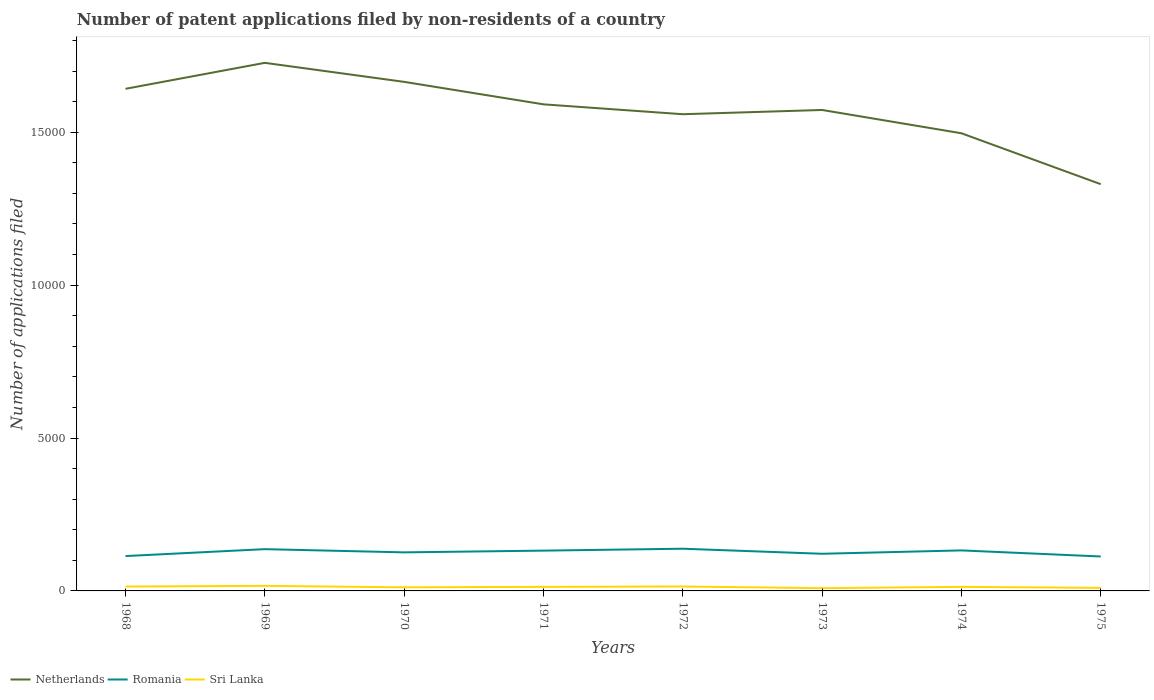How many different coloured lines are there?
Your response must be concise. 3. Across all years, what is the maximum number of applications filed in Romania?
Make the answer very short. 1126. What is the difference between the highest and the second highest number of applications filed in Netherlands?
Your answer should be very brief. 3968. What is the difference between the highest and the lowest number of applications filed in Netherlands?
Your response must be concise. 4. Is the number of applications filed in Netherlands strictly greater than the number of applications filed in Sri Lanka over the years?
Provide a short and direct response. No. How many years are there in the graph?
Make the answer very short. 8. Are the values on the major ticks of Y-axis written in scientific E-notation?
Keep it short and to the point. No. Does the graph contain any zero values?
Provide a short and direct response. No. Where does the legend appear in the graph?
Provide a short and direct response. Bottom left. How many legend labels are there?
Provide a short and direct response. 3. What is the title of the graph?
Offer a terse response. Number of patent applications filed by non-residents of a country. Does "Cayman Islands" appear as one of the legend labels in the graph?
Make the answer very short. No. What is the label or title of the Y-axis?
Your response must be concise. Number of applications filed. What is the Number of applications filed of Netherlands in 1968?
Provide a succinct answer. 1.64e+04. What is the Number of applications filed of Romania in 1968?
Keep it short and to the point. 1140. What is the Number of applications filed of Sri Lanka in 1968?
Offer a very short reply. 143. What is the Number of applications filed in Netherlands in 1969?
Provide a succinct answer. 1.73e+04. What is the Number of applications filed of Romania in 1969?
Keep it short and to the point. 1366. What is the Number of applications filed of Sri Lanka in 1969?
Ensure brevity in your answer.  166. What is the Number of applications filed in Netherlands in 1970?
Your answer should be compact. 1.66e+04. What is the Number of applications filed of Romania in 1970?
Your response must be concise. 1261. What is the Number of applications filed in Sri Lanka in 1970?
Give a very brief answer. 118. What is the Number of applications filed of Netherlands in 1971?
Your answer should be compact. 1.59e+04. What is the Number of applications filed in Romania in 1971?
Your answer should be very brief. 1318. What is the Number of applications filed of Sri Lanka in 1971?
Keep it short and to the point. 133. What is the Number of applications filed in Netherlands in 1972?
Make the answer very short. 1.56e+04. What is the Number of applications filed of Romania in 1972?
Your response must be concise. 1380. What is the Number of applications filed in Sri Lanka in 1972?
Your answer should be very brief. 145. What is the Number of applications filed of Netherlands in 1973?
Your answer should be very brief. 1.57e+04. What is the Number of applications filed of Romania in 1973?
Make the answer very short. 1215. What is the Number of applications filed in Netherlands in 1974?
Ensure brevity in your answer.  1.50e+04. What is the Number of applications filed in Romania in 1974?
Provide a succinct answer. 1325. What is the Number of applications filed in Sri Lanka in 1974?
Make the answer very short. 133. What is the Number of applications filed of Netherlands in 1975?
Offer a terse response. 1.33e+04. What is the Number of applications filed in Romania in 1975?
Keep it short and to the point. 1126. What is the Number of applications filed of Sri Lanka in 1975?
Ensure brevity in your answer.  99. Across all years, what is the maximum Number of applications filed in Netherlands?
Offer a very short reply. 1.73e+04. Across all years, what is the maximum Number of applications filed of Romania?
Offer a terse response. 1380. Across all years, what is the maximum Number of applications filed of Sri Lanka?
Make the answer very short. 166. Across all years, what is the minimum Number of applications filed of Netherlands?
Ensure brevity in your answer.  1.33e+04. Across all years, what is the minimum Number of applications filed in Romania?
Offer a terse response. 1126. Across all years, what is the minimum Number of applications filed in Sri Lanka?
Make the answer very short. 90. What is the total Number of applications filed of Netherlands in the graph?
Ensure brevity in your answer.  1.26e+05. What is the total Number of applications filed in Romania in the graph?
Offer a very short reply. 1.01e+04. What is the total Number of applications filed of Sri Lanka in the graph?
Provide a short and direct response. 1027. What is the difference between the Number of applications filed in Netherlands in 1968 and that in 1969?
Offer a terse response. -849. What is the difference between the Number of applications filed in Romania in 1968 and that in 1969?
Provide a short and direct response. -226. What is the difference between the Number of applications filed in Sri Lanka in 1968 and that in 1969?
Provide a succinct answer. -23. What is the difference between the Number of applications filed in Netherlands in 1968 and that in 1970?
Provide a short and direct response. -227. What is the difference between the Number of applications filed of Romania in 1968 and that in 1970?
Your answer should be very brief. -121. What is the difference between the Number of applications filed in Sri Lanka in 1968 and that in 1970?
Your answer should be very brief. 25. What is the difference between the Number of applications filed of Netherlands in 1968 and that in 1971?
Your response must be concise. 508. What is the difference between the Number of applications filed of Romania in 1968 and that in 1971?
Make the answer very short. -178. What is the difference between the Number of applications filed in Netherlands in 1968 and that in 1972?
Ensure brevity in your answer.  831. What is the difference between the Number of applications filed in Romania in 1968 and that in 1972?
Make the answer very short. -240. What is the difference between the Number of applications filed in Netherlands in 1968 and that in 1973?
Make the answer very short. 692. What is the difference between the Number of applications filed in Romania in 1968 and that in 1973?
Your answer should be very brief. -75. What is the difference between the Number of applications filed of Netherlands in 1968 and that in 1974?
Ensure brevity in your answer.  1454. What is the difference between the Number of applications filed in Romania in 1968 and that in 1974?
Offer a very short reply. -185. What is the difference between the Number of applications filed of Netherlands in 1968 and that in 1975?
Offer a very short reply. 3119. What is the difference between the Number of applications filed of Sri Lanka in 1968 and that in 1975?
Keep it short and to the point. 44. What is the difference between the Number of applications filed of Netherlands in 1969 and that in 1970?
Your answer should be very brief. 622. What is the difference between the Number of applications filed in Romania in 1969 and that in 1970?
Provide a succinct answer. 105. What is the difference between the Number of applications filed in Sri Lanka in 1969 and that in 1970?
Offer a terse response. 48. What is the difference between the Number of applications filed of Netherlands in 1969 and that in 1971?
Offer a very short reply. 1357. What is the difference between the Number of applications filed in Sri Lanka in 1969 and that in 1971?
Your answer should be compact. 33. What is the difference between the Number of applications filed of Netherlands in 1969 and that in 1972?
Your answer should be very brief. 1680. What is the difference between the Number of applications filed of Romania in 1969 and that in 1972?
Offer a terse response. -14. What is the difference between the Number of applications filed of Netherlands in 1969 and that in 1973?
Your response must be concise. 1541. What is the difference between the Number of applications filed in Romania in 1969 and that in 1973?
Give a very brief answer. 151. What is the difference between the Number of applications filed in Netherlands in 1969 and that in 1974?
Keep it short and to the point. 2303. What is the difference between the Number of applications filed in Romania in 1969 and that in 1974?
Make the answer very short. 41. What is the difference between the Number of applications filed in Netherlands in 1969 and that in 1975?
Provide a short and direct response. 3968. What is the difference between the Number of applications filed of Romania in 1969 and that in 1975?
Ensure brevity in your answer.  240. What is the difference between the Number of applications filed in Sri Lanka in 1969 and that in 1975?
Your answer should be very brief. 67. What is the difference between the Number of applications filed in Netherlands in 1970 and that in 1971?
Provide a succinct answer. 735. What is the difference between the Number of applications filed in Romania in 1970 and that in 1971?
Provide a succinct answer. -57. What is the difference between the Number of applications filed of Netherlands in 1970 and that in 1972?
Your answer should be very brief. 1058. What is the difference between the Number of applications filed in Romania in 1970 and that in 1972?
Provide a succinct answer. -119. What is the difference between the Number of applications filed of Netherlands in 1970 and that in 1973?
Provide a succinct answer. 919. What is the difference between the Number of applications filed in Netherlands in 1970 and that in 1974?
Keep it short and to the point. 1681. What is the difference between the Number of applications filed in Romania in 1970 and that in 1974?
Offer a terse response. -64. What is the difference between the Number of applications filed of Sri Lanka in 1970 and that in 1974?
Offer a terse response. -15. What is the difference between the Number of applications filed of Netherlands in 1970 and that in 1975?
Make the answer very short. 3346. What is the difference between the Number of applications filed in Romania in 1970 and that in 1975?
Keep it short and to the point. 135. What is the difference between the Number of applications filed in Netherlands in 1971 and that in 1972?
Ensure brevity in your answer.  323. What is the difference between the Number of applications filed in Romania in 1971 and that in 1972?
Your response must be concise. -62. What is the difference between the Number of applications filed of Netherlands in 1971 and that in 1973?
Keep it short and to the point. 184. What is the difference between the Number of applications filed in Romania in 1971 and that in 1973?
Provide a succinct answer. 103. What is the difference between the Number of applications filed in Netherlands in 1971 and that in 1974?
Your response must be concise. 946. What is the difference between the Number of applications filed in Romania in 1971 and that in 1974?
Provide a succinct answer. -7. What is the difference between the Number of applications filed of Sri Lanka in 1971 and that in 1974?
Your answer should be very brief. 0. What is the difference between the Number of applications filed of Netherlands in 1971 and that in 1975?
Your response must be concise. 2611. What is the difference between the Number of applications filed of Romania in 1971 and that in 1975?
Your answer should be very brief. 192. What is the difference between the Number of applications filed of Sri Lanka in 1971 and that in 1975?
Your response must be concise. 34. What is the difference between the Number of applications filed of Netherlands in 1972 and that in 1973?
Your answer should be compact. -139. What is the difference between the Number of applications filed of Romania in 1972 and that in 1973?
Keep it short and to the point. 165. What is the difference between the Number of applications filed of Sri Lanka in 1972 and that in 1973?
Your response must be concise. 55. What is the difference between the Number of applications filed in Netherlands in 1972 and that in 1974?
Provide a short and direct response. 623. What is the difference between the Number of applications filed of Romania in 1972 and that in 1974?
Offer a terse response. 55. What is the difference between the Number of applications filed in Sri Lanka in 1972 and that in 1974?
Offer a very short reply. 12. What is the difference between the Number of applications filed of Netherlands in 1972 and that in 1975?
Make the answer very short. 2288. What is the difference between the Number of applications filed in Romania in 1972 and that in 1975?
Make the answer very short. 254. What is the difference between the Number of applications filed of Sri Lanka in 1972 and that in 1975?
Ensure brevity in your answer.  46. What is the difference between the Number of applications filed of Netherlands in 1973 and that in 1974?
Ensure brevity in your answer.  762. What is the difference between the Number of applications filed in Romania in 1973 and that in 1974?
Ensure brevity in your answer.  -110. What is the difference between the Number of applications filed of Sri Lanka in 1973 and that in 1974?
Provide a succinct answer. -43. What is the difference between the Number of applications filed in Netherlands in 1973 and that in 1975?
Keep it short and to the point. 2427. What is the difference between the Number of applications filed in Romania in 1973 and that in 1975?
Ensure brevity in your answer.  89. What is the difference between the Number of applications filed in Netherlands in 1974 and that in 1975?
Provide a succinct answer. 1665. What is the difference between the Number of applications filed of Romania in 1974 and that in 1975?
Your answer should be very brief. 199. What is the difference between the Number of applications filed of Sri Lanka in 1974 and that in 1975?
Offer a very short reply. 34. What is the difference between the Number of applications filed in Netherlands in 1968 and the Number of applications filed in Romania in 1969?
Offer a very short reply. 1.51e+04. What is the difference between the Number of applications filed in Netherlands in 1968 and the Number of applications filed in Sri Lanka in 1969?
Your answer should be very brief. 1.63e+04. What is the difference between the Number of applications filed in Romania in 1968 and the Number of applications filed in Sri Lanka in 1969?
Your answer should be compact. 974. What is the difference between the Number of applications filed of Netherlands in 1968 and the Number of applications filed of Romania in 1970?
Offer a terse response. 1.52e+04. What is the difference between the Number of applications filed in Netherlands in 1968 and the Number of applications filed in Sri Lanka in 1970?
Your response must be concise. 1.63e+04. What is the difference between the Number of applications filed of Romania in 1968 and the Number of applications filed of Sri Lanka in 1970?
Offer a very short reply. 1022. What is the difference between the Number of applications filed of Netherlands in 1968 and the Number of applications filed of Romania in 1971?
Offer a terse response. 1.51e+04. What is the difference between the Number of applications filed of Netherlands in 1968 and the Number of applications filed of Sri Lanka in 1971?
Offer a terse response. 1.63e+04. What is the difference between the Number of applications filed of Romania in 1968 and the Number of applications filed of Sri Lanka in 1971?
Offer a terse response. 1007. What is the difference between the Number of applications filed in Netherlands in 1968 and the Number of applications filed in Romania in 1972?
Ensure brevity in your answer.  1.50e+04. What is the difference between the Number of applications filed in Netherlands in 1968 and the Number of applications filed in Sri Lanka in 1972?
Your answer should be compact. 1.63e+04. What is the difference between the Number of applications filed of Romania in 1968 and the Number of applications filed of Sri Lanka in 1972?
Ensure brevity in your answer.  995. What is the difference between the Number of applications filed of Netherlands in 1968 and the Number of applications filed of Romania in 1973?
Your answer should be compact. 1.52e+04. What is the difference between the Number of applications filed of Netherlands in 1968 and the Number of applications filed of Sri Lanka in 1973?
Provide a short and direct response. 1.63e+04. What is the difference between the Number of applications filed in Romania in 1968 and the Number of applications filed in Sri Lanka in 1973?
Your answer should be very brief. 1050. What is the difference between the Number of applications filed in Netherlands in 1968 and the Number of applications filed in Romania in 1974?
Offer a very short reply. 1.51e+04. What is the difference between the Number of applications filed in Netherlands in 1968 and the Number of applications filed in Sri Lanka in 1974?
Offer a very short reply. 1.63e+04. What is the difference between the Number of applications filed in Romania in 1968 and the Number of applications filed in Sri Lanka in 1974?
Keep it short and to the point. 1007. What is the difference between the Number of applications filed in Netherlands in 1968 and the Number of applications filed in Romania in 1975?
Provide a short and direct response. 1.53e+04. What is the difference between the Number of applications filed in Netherlands in 1968 and the Number of applications filed in Sri Lanka in 1975?
Provide a succinct answer. 1.63e+04. What is the difference between the Number of applications filed of Romania in 1968 and the Number of applications filed of Sri Lanka in 1975?
Your answer should be compact. 1041. What is the difference between the Number of applications filed of Netherlands in 1969 and the Number of applications filed of Romania in 1970?
Provide a short and direct response. 1.60e+04. What is the difference between the Number of applications filed of Netherlands in 1969 and the Number of applications filed of Sri Lanka in 1970?
Your answer should be very brief. 1.72e+04. What is the difference between the Number of applications filed in Romania in 1969 and the Number of applications filed in Sri Lanka in 1970?
Ensure brevity in your answer.  1248. What is the difference between the Number of applications filed of Netherlands in 1969 and the Number of applications filed of Romania in 1971?
Your answer should be compact. 1.60e+04. What is the difference between the Number of applications filed of Netherlands in 1969 and the Number of applications filed of Sri Lanka in 1971?
Keep it short and to the point. 1.71e+04. What is the difference between the Number of applications filed of Romania in 1969 and the Number of applications filed of Sri Lanka in 1971?
Offer a terse response. 1233. What is the difference between the Number of applications filed in Netherlands in 1969 and the Number of applications filed in Romania in 1972?
Your answer should be compact. 1.59e+04. What is the difference between the Number of applications filed of Netherlands in 1969 and the Number of applications filed of Sri Lanka in 1972?
Your response must be concise. 1.71e+04. What is the difference between the Number of applications filed of Romania in 1969 and the Number of applications filed of Sri Lanka in 1972?
Your answer should be very brief. 1221. What is the difference between the Number of applications filed in Netherlands in 1969 and the Number of applications filed in Romania in 1973?
Your response must be concise. 1.61e+04. What is the difference between the Number of applications filed in Netherlands in 1969 and the Number of applications filed in Sri Lanka in 1973?
Your answer should be compact. 1.72e+04. What is the difference between the Number of applications filed of Romania in 1969 and the Number of applications filed of Sri Lanka in 1973?
Provide a short and direct response. 1276. What is the difference between the Number of applications filed in Netherlands in 1969 and the Number of applications filed in Romania in 1974?
Give a very brief answer. 1.59e+04. What is the difference between the Number of applications filed of Netherlands in 1969 and the Number of applications filed of Sri Lanka in 1974?
Give a very brief answer. 1.71e+04. What is the difference between the Number of applications filed of Romania in 1969 and the Number of applications filed of Sri Lanka in 1974?
Your response must be concise. 1233. What is the difference between the Number of applications filed in Netherlands in 1969 and the Number of applications filed in Romania in 1975?
Keep it short and to the point. 1.61e+04. What is the difference between the Number of applications filed in Netherlands in 1969 and the Number of applications filed in Sri Lanka in 1975?
Offer a terse response. 1.72e+04. What is the difference between the Number of applications filed in Romania in 1969 and the Number of applications filed in Sri Lanka in 1975?
Make the answer very short. 1267. What is the difference between the Number of applications filed in Netherlands in 1970 and the Number of applications filed in Romania in 1971?
Ensure brevity in your answer.  1.53e+04. What is the difference between the Number of applications filed in Netherlands in 1970 and the Number of applications filed in Sri Lanka in 1971?
Provide a succinct answer. 1.65e+04. What is the difference between the Number of applications filed in Romania in 1970 and the Number of applications filed in Sri Lanka in 1971?
Keep it short and to the point. 1128. What is the difference between the Number of applications filed in Netherlands in 1970 and the Number of applications filed in Romania in 1972?
Make the answer very short. 1.53e+04. What is the difference between the Number of applications filed of Netherlands in 1970 and the Number of applications filed of Sri Lanka in 1972?
Your answer should be compact. 1.65e+04. What is the difference between the Number of applications filed in Romania in 1970 and the Number of applications filed in Sri Lanka in 1972?
Make the answer very short. 1116. What is the difference between the Number of applications filed of Netherlands in 1970 and the Number of applications filed of Romania in 1973?
Your answer should be very brief. 1.54e+04. What is the difference between the Number of applications filed of Netherlands in 1970 and the Number of applications filed of Sri Lanka in 1973?
Offer a very short reply. 1.66e+04. What is the difference between the Number of applications filed in Romania in 1970 and the Number of applications filed in Sri Lanka in 1973?
Your response must be concise. 1171. What is the difference between the Number of applications filed in Netherlands in 1970 and the Number of applications filed in Romania in 1974?
Your answer should be compact. 1.53e+04. What is the difference between the Number of applications filed of Netherlands in 1970 and the Number of applications filed of Sri Lanka in 1974?
Provide a short and direct response. 1.65e+04. What is the difference between the Number of applications filed in Romania in 1970 and the Number of applications filed in Sri Lanka in 1974?
Offer a very short reply. 1128. What is the difference between the Number of applications filed in Netherlands in 1970 and the Number of applications filed in Romania in 1975?
Your answer should be compact. 1.55e+04. What is the difference between the Number of applications filed of Netherlands in 1970 and the Number of applications filed of Sri Lanka in 1975?
Make the answer very short. 1.65e+04. What is the difference between the Number of applications filed in Romania in 1970 and the Number of applications filed in Sri Lanka in 1975?
Provide a short and direct response. 1162. What is the difference between the Number of applications filed in Netherlands in 1971 and the Number of applications filed in Romania in 1972?
Keep it short and to the point. 1.45e+04. What is the difference between the Number of applications filed of Netherlands in 1971 and the Number of applications filed of Sri Lanka in 1972?
Ensure brevity in your answer.  1.58e+04. What is the difference between the Number of applications filed in Romania in 1971 and the Number of applications filed in Sri Lanka in 1972?
Ensure brevity in your answer.  1173. What is the difference between the Number of applications filed of Netherlands in 1971 and the Number of applications filed of Romania in 1973?
Offer a terse response. 1.47e+04. What is the difference between the Number of applications filed in Netherlands in 1971 and the Number of applications filed in Sri Lanka in 1973?
Your response must be concise. 1.58e+04. What is the difference between the Number of applications filed in Romania in 1971 and the Number of applications filed in Sri Lanka in 1973?
Provide a succinct answer. 1228. What is the difference between the Number of applications filed in Netherlands in 1971 and the Number of applications filed in Romania in 1974?
Your answer should be very brief. 1.46e+04. What is the difference between the Number of applications filed in Netherlands in 1971 and the Number of applications filed in Sri Lanka in 1974?
Your response must be concise. 1.58e+04. What is the difference between the Number of applications filed in Romania in 1971 and the Number of applications filed in Sri Lanka in 1974?
Make the answer very short. 1185. What is the difference between the Number of applications filed in Netherlands in 1971 and the Number of applications filed in Romania in 1975?
Your response must be concise. 1.48e+04. What is the difference between the Number of applications filed of Netherlands in 1971 and the Number of applications filed of Sri Lanka in 1975?
Offer a terse response. 1.58e+04. What is the difference between the Number of applications filed of Romania in 1971 and the Number of applications filed of Sri Lanka in 1975?
Keep it short and to the point. 1219. What is the difference between the Number of applications filed in Netherlands in 1972 and the Number of applications filed in Romania in 1973?
Make the answer very short. 1.44e+04. What is the difference between the Number of applications filed in Netherlands in 1972 and the Number of applications filed in Sri Lanka in 1973?
Your answer should be compact. 1.55e+04. What is the difference between the Number of applications filed of Romania in 1972 and the Number of applications filed of Sri Lanka in 1973?
Give a very brief answer. 1290. What is the difference between the Number of applications filed of Netherlands in 1972 and the Number of applications filed of Romania in 1974?
Offer a terse response. 1.43e+04. What is the difference between the Number of applications filed of Netherlands in 1972 and the Number of applications filed of Sri Lanka in 1974?
Give a very brief answer. 1.55e+04. What is the difference between the Number of applications filed of Romania in 1972 and the Number of applications filed of Sri Lanka in 1974?
Provide a short and direct response. 1247. What is the difference between the Number of applications filed of Netherlands in 1972 and the Number of applications filed of Romania in 1975?
Offer a very short reply. 1.45e+04. What is the difference between the Number of applications filed in Netherlands in 1972 and the Number of applications filed in Sri Lanka in 1975?
Make the answer very short. 1.55e+04. What is the difference between the Number of applications filed of Romania in 1972 and the Number of applications filed of Sri Lanka in 1975?
Keep it short and to the point. 1281. What is the difference between the Number of applications filed of Netherlands in 1973 and the Number of applications filed of Romania in 1974?
Provide a short and direct response. 1.44e+04. What is the difference between the Number of applications filed in Netherlands in 1973 and the Number of applications filed in Sri Lanka in 1974?
Provide a short and direct response. 1.56e+04. What is the difference between the Number of applications filed in Romania in 1973 and the Number of applications filed in Sri Lanka in 1974?
Make the answer very short. 1082. What is the difference between the Number of applications filed of Netherlands in 1973 and the Number of applications filed of Romania in 1975?
Provide a short and direct response. 1.46e+04. What is the difference between the Number of applications filed in Netherlands in 1973 and the Number of applications filed in Sri Lanka in 1975?
Provide a short and direct response. 1.56e+04. What is the difference between the Number of applications filed in Romania in 1973 and the Number of applications filed in Sri Lanka in 1975?
Make the answer very short. 1116. What is the difference between the Number of applications filed in Netherlands in 1974 and the Number of applications filed in Romania in 1975?
Offer a very short reply. 1.38e+04. What is the difference between the Number of applications filed in Netherlands in 1974 and the Number of applications filed in Sri Lanka in 1975?
Ensure brevity in your answer.  1.49e+04. What is the difference between the Number of applications filed of Romania in 1974 and the Number of applications filed of Sri Lanka in 1975?
Give a very brief answer. 1226. What is the average Number of applications filed of Netherlands per year?
Your response must be concise. 1.57e+04. What is the average Number of applications filed of Romania per year?
Your answer should be compact. 1266.38. What is the average Number of applications filed of Sri Lanka per year?
Give a very brief answer. 128.38. In the year 1968, what is the difference between the Number of applications filed in Netherlands and Number of applications filed in Romania?
Your response must be concise. 1.53e+04. In the year 1968, what is the difference between the Number of applications filed in Netherlands and Number of applications filed in Sri Lanka?
Provide a succinct answer. 1.63e+04. In the year 1968, what is the difference between the Number of applications filed of Romania and Number of applications filed of Sri Lanka?
Keep it short and to the point. 997. In the year 1969, what is the difference between the Number of applications filed in Netherlands and Number of applications filed in Romania?
Ensure brevity in your answer.  1.59e+04. In the year 1969, what is the difference between the Number of applications filed of Netherlands and Number of applications filed of Sri Lanka?
Keep it short and to the point. 1.71e+04. In the year 1969, what is the difference between the Number of applications filed of Romania and Number of applications filed of Sri Lanka?
Provide a succinct answer. 1200. In the year 1970, what is the difference between the Number of applications filed in Netherlands and Number of applications filed in Romania?
Offer a terse response. 1.54e+04. In the year 1970, what is the difference between the Number of applications filed of Netherlands and Number of applications filed of Sri Lanka?
Your response must be concise. 1.65e+04. In the year 1970, what is the difference between the Number of applications filed in Romania and Number of applications filed in Sri Lanka?
Offer a very short reply. 1143. In the year 1971, what is the difference between the Number of applications filed in Netherlands and Number of applications filed in Romania?
Make the answer very short. 1.46e+04. In the year 1971, what is the difference between the Number of applications filed in Netherlands and Number of applications filed in Sri Lanka?
Your answer should be compact. 1.58e+04. In the year 1971, what is the difference between the Number of applications filed in Romania and Number of applications filed in Sri Lanka?
Your answer should be very brief. 1185. In the year 1972, what is the difference between the Number of applications filed of Netherlands and Number of applications filed of Romania?
Make the answer very short. 1.42e+04. In the year 1972, what is the difference between the Number of applications filed in Netherlands and Number of applications filed in Sri Lanka?
Provide a short and direct response. 1.54e+04. In the year 1972, what is the difference between the Number of applications filed of Romania and Number of applications filed of Sri Lanka?
Ensure brevity in your answer.  1235. In the year 1973, what is the difference between the Number of applications filed of Netherlands and Number of applications filed of Romania?
Keep it short and to the point. 1.45e+04. In the year 1973, what is the difference between the Number of applications filed in Netherlands and Number of applications filed in Sri Lanka?
Offer a terse response. 1.56e+04. In the year 1973, what is the difference between the Number of applications filed of Romania and Number of applications filed of Sri Lanka?
Ensure brevity in your answer.  1125. In the year 1974, what is the difference between the Number of applications filed in Netherlands and Number of applications filed in Romania?
Keep it short and to the point. 1.36e+04. In the year 1974, what is the difference between the Number of applications filed of Netherlands and Number of applications filed of Sri Lanka?
Keep it short and to the point. 1.48e+04. In the year 1974, what is the difference between the Number of applications filed of Romania and Number of applications filed of Sri Lanka?
Provide a succinct answer. 1192. In the year 1975, what is the difference between the Number of applications filed in Netherlands and Number of applications filed in Romania?
Offer a terse response. 1.22e+04. In the year 1975, what is the difference between the Number of applications filed of Netherlands and Number of applications filed of Sri Lanka?
Ensure brevity in your answer.  1.32e+04. In the year 1975, what is the difference between the Number of applications filed in Romania and Number of applications filed in Sri Lanka?
Keep it short and to the point. 1027. What is the ratio of the Number of applications filed in Netherlands in 1968 to that in 1969?
Provide a short and direct response. 0.95. What is the ratio of the Number of applications filed in Romania in 1968 to that in 1969?
Your answer should be very brief. 0.83. What is the ratio of the Number of applications filed in Sri Lanka in 1968 to that in 1969?
Ensure brevity in your answer.  0.86. What is the ratio of the Number of applications filed in Netherlands in 1968 to that in 1970?
Your answer should be compact. 0.99. What is the ratio of the Number of applications filed of Romania in 1968 to that in 1970?
Your response must be concise. 0.9. What is the ratio of the Number of applications filed of Sri Lanka in 1968 to that in 1970?
Your answer should be very brief. 1.21. What is the ratio of the Number of applications filed of Netherlands in 1968 to that in 1971?
Offer a terse response. 1.03. What is the ratio of the Number of applications filed in Romania in 1968 to that in 1971?
Your response must be concise. 0.86. What is the ratio of the Number of applications filed in Sri Lanka in 1968 to that in 1971?
Your answer should be compact. 1.08. What is the ratio of the Number of applications filed of Netherlands in 1968 to that in 1972?
Your answer should be very brief. 1.05. What is the ratio of the Number of applications filed of Romania in 1968 to that in 1972?
Make the answer very short. 0.83. What is the ratio of the Number of applications filed of Sri Lanka in 1968 to that in 1972?
Provide a succinct answer. 0.99. What is the ratio of the Number of applications filed of Netherlands in 1968 to that in 1973?
Your answer should be compact. 1.04. What is the ratio of the Number of applications filed in Romania in 1968 to that in 1973?
Your answer should be compact. 0.94. What is the ratio of the Number of applications filed in Sri Lanka in 1968 to that in 1973?
Your answer should be compact. 1.59. What is the ratio of the Number of applications filed in Netherlands in 1968 to that in 1974?
Give a very brief answer. 1.1. What is the ratio of the Number of applications filed of Romania in 1968 to that in 1974?
Your answer should be very brief. 0.86. What is the ratio of the Number of applications filed of Sri Lanka in 1968 to that in 1974?
Keep it short and to the point. 1.08. What is the ratio of the Number of applications filed in Netherlands in 1968 to that in 1975?
Offer a terse response. 1.23. What is the ratio of the Number of applications filed of Romania in 1968 to that in 1975?
Ensure brevity in your answer.  1.01. What is the ratio of the Number of applications filed in Sri Lanka in 1968 to that in 1975?
Your response must be concise. 1.44. What is the ratio of the Number of applications filed in Netherlands in 1969 to that in 1970?
Provide a succinct answer. 1.04. What is the ratio of the Number of applications filed of Sri Lanka in 1969 to that in 1970?
Offer a very short reply. 1.41. What is the ratio of the Number of applications filed in Netherlands in 1969 to that in 1971?
Ensure brevity in your answer.  1.09. What is the ratio of the Number of applications filed in Romania in 1969 to that in 1971?
Ensure brevity in your answer.  1.04. What is the ratio of the Number of applications filed in Sri Lanka in 1969 to that in 1971?
Keep it short and to the point. 1.25. What is the ratio of the Number of applications filed of Netherlands in 1969 to that in 1972?
Keep it short and to the point. 1.11. What is the ratio of the Number of applications filed of Sri Lanka in 1969 to that in 1972?
Provide a succinct answer. 1.14. What is the ratio of the Number of applications filed of Netherlands in 1969 to that in 1973?
Give a very brief answer. 1.1. What is the ratio of the Number of applications filed in Romania in 1969 to that in 1973?
Keep it short and to the point. 1.12. What is the ratio of the Number of applications filed in Sri Lanka in 1969 to that in 1973?
Provide a short and direct response. 1.84. What is the ratio of the Number of applications filed of Netherlands in 1969 to that in 1974?
Keep it short and to the point. 1.15. What is the ratio of the Number of applications filed in Romania in 1969 to that in 1974?
Make the answer very short. 1.03. What is the ratio of the Number of applications filed in Sri Lanka in 1969 to that in 1974?
Make the answer very short. 1.25. What is the ratio of the Number of applications filed in Netherlands in 1969 to that in 1975?
Make the answer very short. 1.3. What is the ratio of the Number of applications filed in Romania in 1969 to that in 1975?
Offer a very short reply. 1.21. What is the ratio of the Number of applications filed of Sri Lanka in 1969 to that in 1975?
Your answer should be very brief. 1.68. What is the ratio of the Number of applications filed in Netherlands in 1970 to that in 1971?
Your answer should be compact. 1.05. What is the ratio of the Number of applications filed of Romania in 1970 to that in 1971?
Ensure brevity in your answer.  0.96. What is the ratio of the Number of applications filed of Sri Lanka in 1970 to that in 1971?
Your answer should be compact. 0.89. What is the ratio of the Number of applications filed of Netherlands in 1970 to that in 1972?
Provide a short and direct response. 1.07. What is the ratio of the Number of applications filed of Romania in 1970 to that in 1972?
Keep it short and to the point. 0.91. What is the ratio of the Number of applications filed of Sri Lanka in 1970 to that in 1972?
Your answer should be compact. 0.81. What is the ratio of the Number of applications filed of Netherlands in 1970 to that in 1973?
Offer a terse response. 1.06. What is the ratio of the Number of applications filed of Romania in 1970 to that in 1973?
Your response must be concise. 1.04. What is the ratio of the Number of applications filed of Sri Lanka in 1970 to that in 1973?
Your answer should be compact. 1.31. What is the ratio of the Number of applications filed of Netherlands in 1970 to that in 1974?
Ensure brevity in your answer.  1.11. What is the ratio of the Number of applications filed in Romania in 1970 to that in 1974?
Make the answer very short. 0.95. What is the ratio of the Number of applications filed in Sri Lanka in 1970 to that in 1974?
Make the answer very short. 0.89. What is the ratio of the Number of applications filed in Netherlands in 1970 to that in 1975?
Give a very brief answer. 1.25. What is the ratio of the Number of applications filed of Romania in 1970 to that in 1975?
Provide a short and direct response. 1.12. What is the ratio of the Number of applications filed of Sri Lanka in 1970 to that in 1975?
Make the answer very short. 1.19. What is the ratio of the Number of applications filed in Netherlands in 1971 to that in 1972?
Your response must be concise. 1.02. What is the ratio of the Number of applications filed in Romania in 1971 to that in 1972?
Give a very brief answer. 0.96. What is the ratio of the Number of applications filed in Sri Lanka in 1971 to that in 1972?
Give a very brief answer. 0.92. What is the ratio of the Number of applications filed of Netherlands in 1971 to that in 1973?
Offer a terse response. 1.01. What is the ratio of the Number of applications filed of Romania in 1971 to that in 1973?
Make the answer very short. 1.08. What is the ratio of the Number of applications filed in Sri Lanka in 1971 to that in 1973?
Keep it short and to the point. 1.48. What is the ratio of the Number of applications filed of Netherlands in 1971 to that in 1974?
Offer a very short reply. 1.06. What is the ratio of the Number of applications filed in Sri Lanka in 1971 to that in 1974?
Offer a very short reply. 1. What is the ratio of the Number of applications filed in Netherlands in 1971 to that in 1975?
Your answer should be compact. 1.2. What is the ratio of the Number of applications filed of Romania in 1971 to that in 1975?
Ensure brevity in your answer.  1.17. What is the ratio of the Number of applications filed in Sri Lanka in 1971 to that in 1975?
Give a very brief answer. 1.34. What is the ratio of the Number of applications filed of Romania in 1972 to that in 1973?
Offer a very short reply. 1.14. What is the ratio of the Number of applications filed in Sri Lanka in 1972 to that in 1973?
Ensure brevity in your answer.  1.61. What is the ratio of the Number of applications filed of Netherlands in 1972 to that in 1974?
Your answer should be compact. 1.04. What is the ratio of the Number of applications filed in Romania in 1972 to that in 1974?
Your response must be concise. 1.04. What is the ratio of the Number of applications filed in Sri Lanka in 1972 to that in 1974?
Your answer should be very brief. 1.09. What is the ratio of the Number of applications filed of Netherlands in 1972 to that in 1975?
Provide a short and direct response. 1.17. What is the ratio of the Number of applications filed of Romania in 1972 to that in 1975?
Make the answer very short. 1.23. What is the ratio of the Number of applications filed in Sri Lanka in 1972 to that in 1975?
Offer a terse response. 1.46. What is the ratio of the Number of applications filed of Netherlands in 1973 to that in 1974?
Make the answer very short. 1.05. What is the ratio of the Number of applications filed of Romania in 1973 to that in 1974?
Your answer should be compact. 0.92. What is the ratio of the Number of applications filed of Sri Lanka in 1973 to that in 1974?
Provide a succinct answer. 0.68. What is the ratio of the Number of applications filed of Netherlands in 1973 to that in 1975?
Offer a terse response. 1.18. What is the ratio of the Number of applications filed in Romania in 1973 to that in 1975?
Keep it short and to the point. 1.08. What is the ratio of the Number of applications filed of Sri Lanka in 1973 to that in 1975?
Make the answer very short. 0.91. What is the ratio of the Number of applications filed in Netherlands in 1974 to that in 1975?
Your response must be concise. 1.13. What is the ratio of the Number of applications filed of Romania in 1974 to that in 1975?
Provide a short and direct response. 1.18. What is the ratio of the Number of applications filed of Sri Lanka in 1974 to that in 1975?
Provide a succinct answer. 1.34. What is the difference between the highest and the second highest Number of applications filed of Netherlands?
Offer a terse response. 622. What is the difference between the highest and the second highest Number of applications filed of Romania?
Your answer should be compact. 14. What is the difference between the highest and the lowest Number of applications filed of Netherlands?
Your answer should be very brief. 3968. What is the difference between the highest and the lowest Number of applications filed in Romania?
Your response must be concise. 254. What is the difference between the highest and the lowest Number of applications filed of Sri Lanka?
Provide a short and direct response. 76. 